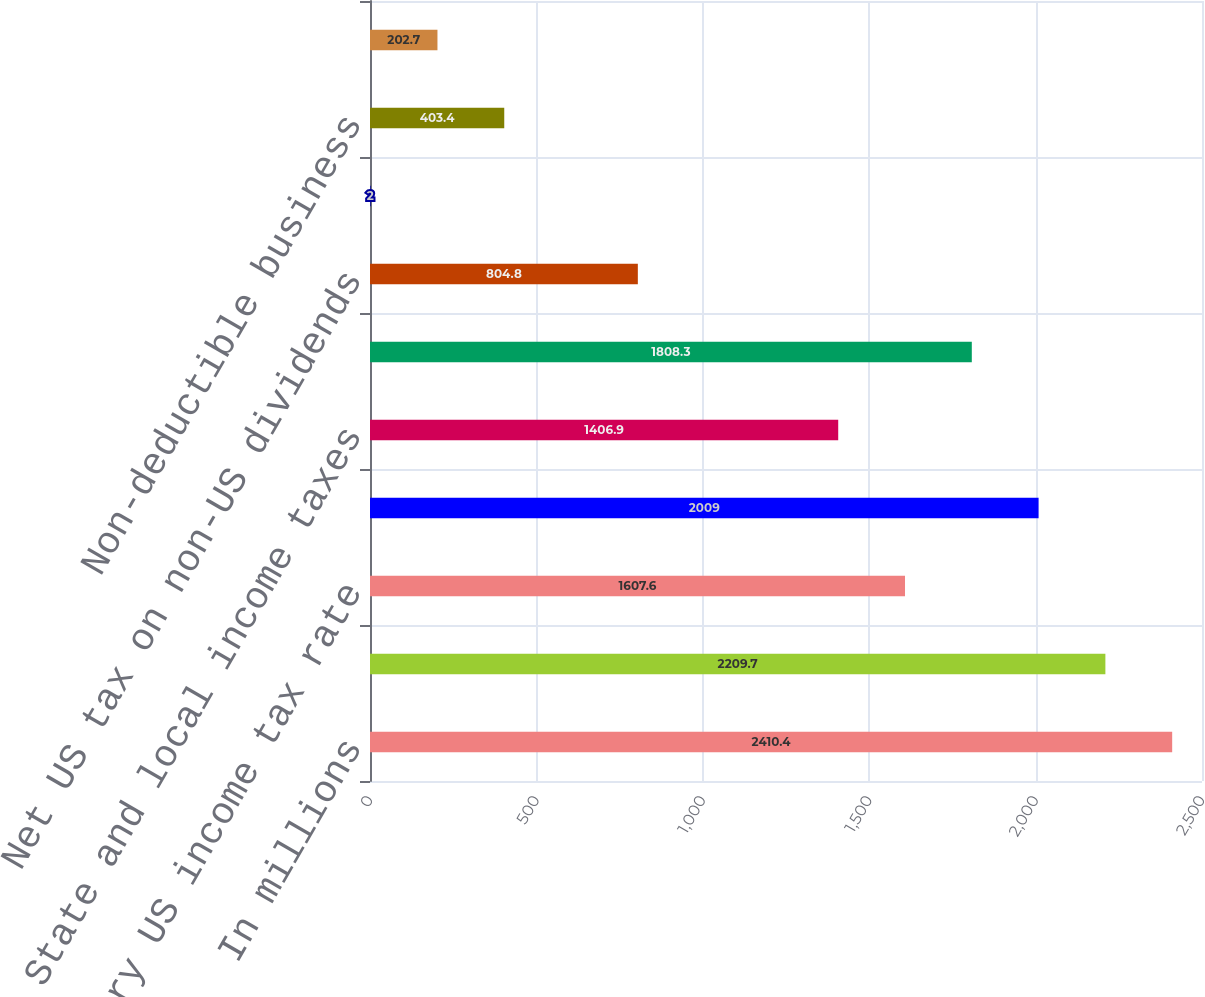Convert chart to OTSL. <chart><loc_0><loc_0><loc_500><loc_500><bar_chart><fcel>In millions<fcel>Earnings (loss) from<fcel>Statutory US income tax rate<fcel>Tax expense (benefit) using<fcel>State and local income taxes<fcel>Tax rate and permanent<fcel>Net US tax on non-US dividends<fcel>Tax benefit on export sales<fcel>Non-deductible business<fcel>Retirement plan dividends<nl><fcel>2410.4<fcel>2209.7<fcel>1607.6<fcel>2009<fcel>1406.9<fcel>1808.3<fcel>804.8<fcel>2<fcel>403.4<fcel>202.7<nl></chart> 